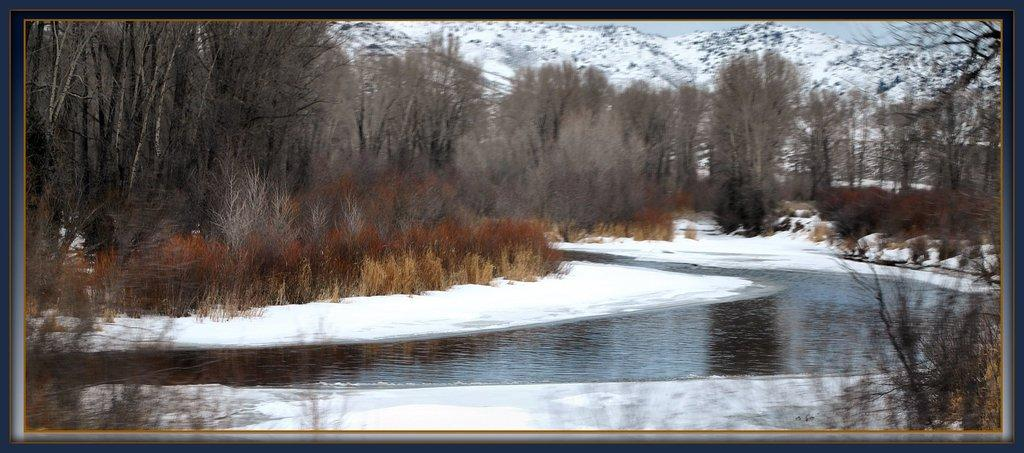What is the primary element visible in the image? There is water in the image. What type of weather condition is suggested by the presence of snow? The presence of snow on the sides of the image suggests a cold or wintry weather condition. What type of vegetation can be seen in the image? There are plants and trees in the image. What is used to frame the image? There is a border for the image. What color is the rose in the image? There is no rose present in the image. What type of view can be seen from the location of the image? The image does not provide a view or a specific location, so it is not possible to determine the type of view. 